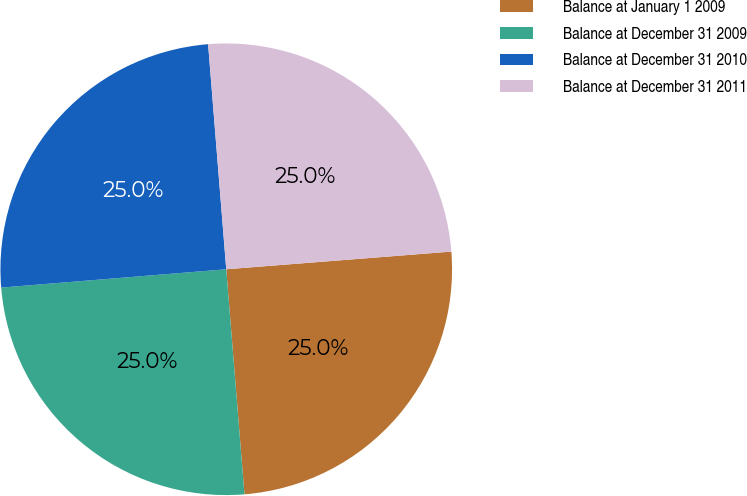<chart> <loc_0><loc_0><loc_500><loc_500><pie_chart><fcel>Balance at January 1 2009<fcel>Balance at December 31 2009<fcel>Balance at December 31 2010<fcel>Balance at December 31 2011<nl><fcel>24.96%<fcel>24.99%<fcel>25.01%<fcel>25.03%<nl></chart> 